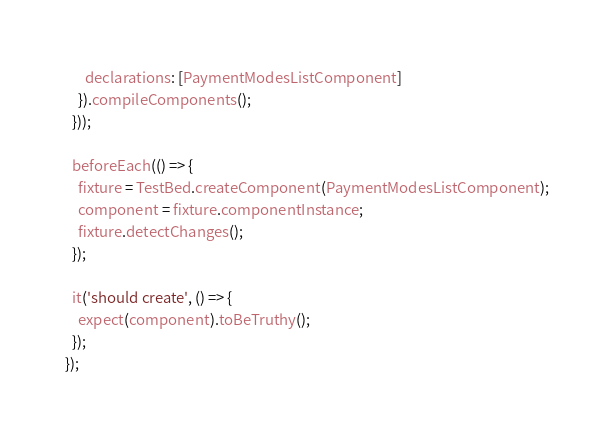Convert code to text. <code><loc_0><loc_0><loc_500><loc_500><_TypeScript_>      declarations: [PaymentModesListComponent]
    }).compileComponents();
  }));

  beforeEach(() => {
    fixture = TestBed.createComponent(PaymentModesListComponent);
    component = fixture.componentInstance;
    fixture.detectChanges();
  });

  it('should create', () => {
    expect(component).toBeTruthy();
  });
});
</code> 